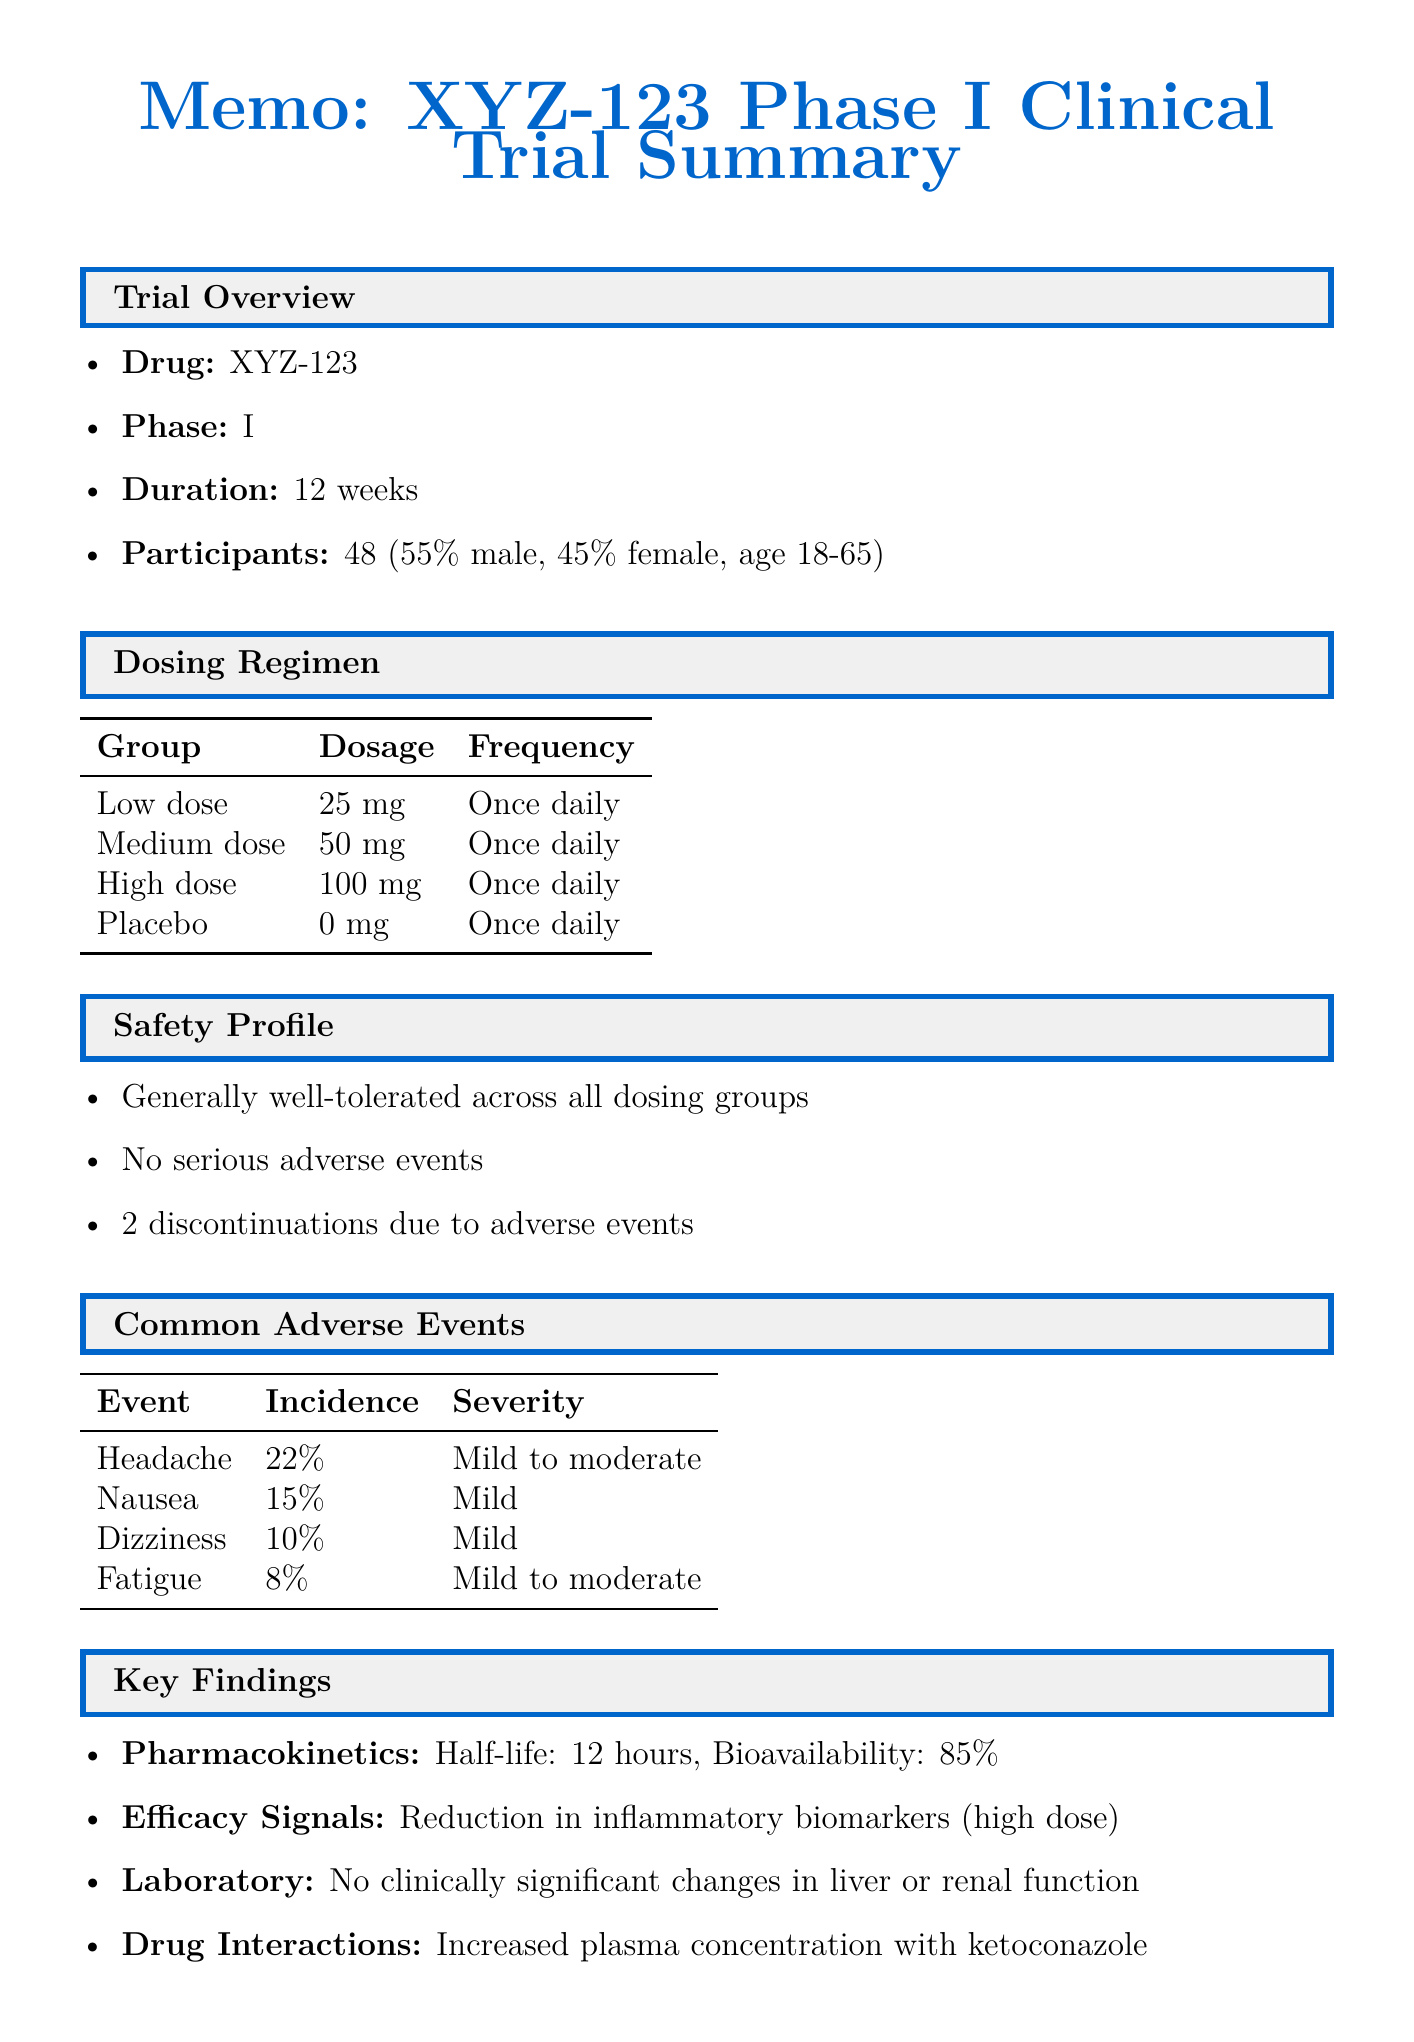What is the phase of the clinical trial? The phase is stated in the trial overview section of the document.
Answer: Phase I How many participants were involved in the trial? The number of participants is listed in the trial overview section.
Answer: 48 What is the dosage of the high dose group? The high dose group's dosage is specified in the dosing regimen table.
Answer: 100 mg What percentage of participants experienced headaches? The incidence of headaches is mentioned in the common adverse events table.
Answer: 22% What was observed in terms of adverse events leading to discontinuations? The discontinuations due to adverse events are noted in the safety profile section.
Answer: 2 What is the half-life of drug XYZ-123? The half-life is provided under the pharmacokinetics section of the document.
Answer: 12 hours What was the conclusion of the trial regarding drug XYZ-123? The conclusion summarizes the overall finding of the trial presented at the end of the document.
Answer: Acceptable safety profile Which drug was noted to interact with XYZ-123? The interacting drug is mentioned in the drug interactions section.
Answer: Ketoconazole What were the exploratory efficacy endpoints mentioned? The exploratory endpoints are listed in the efficacy signals section.
Answer: Reduction in inflammatory biomarkers observed in high dose group, Potential dose-dependent effect on target engagement 